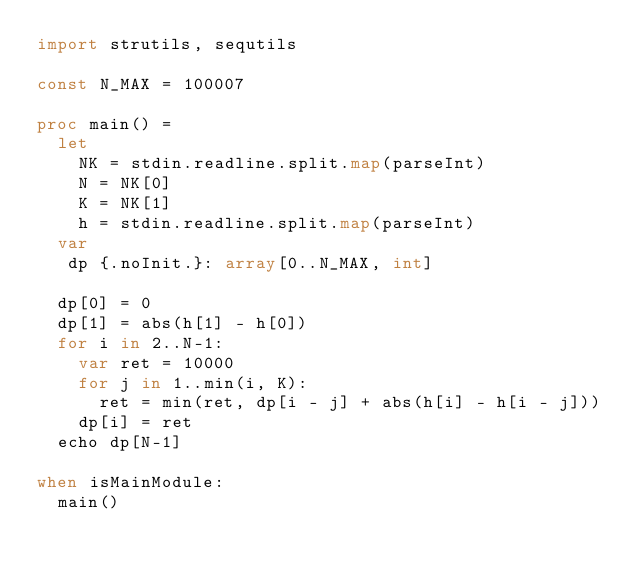<code> <loc_0><loc_0><loc_500><loc_500><_Nim_>import strutils, sequtils

const N_MAX = 100007

proc main() =
  let
    NK = stdin.readline.split.map(parseInt)
    N = NK[0]
    K = NK[1]
    h = stdin.readline.split.map(parseInt)
  var
   dp {.noInit.}: array[0..N_MAX, int]

  dp[0] = 0
  dp[1] = abs(h[1] - h[0])
  for i in 2..N-1:
    var ret = 10000
    for j in 1..min(i, K):
      ret = min(ret, dp[i - j] + abs(h[i] - h[i - j]))
    dp[i] = ret
  echo dp[N-1]

when isMainModule:
  main()</code> 